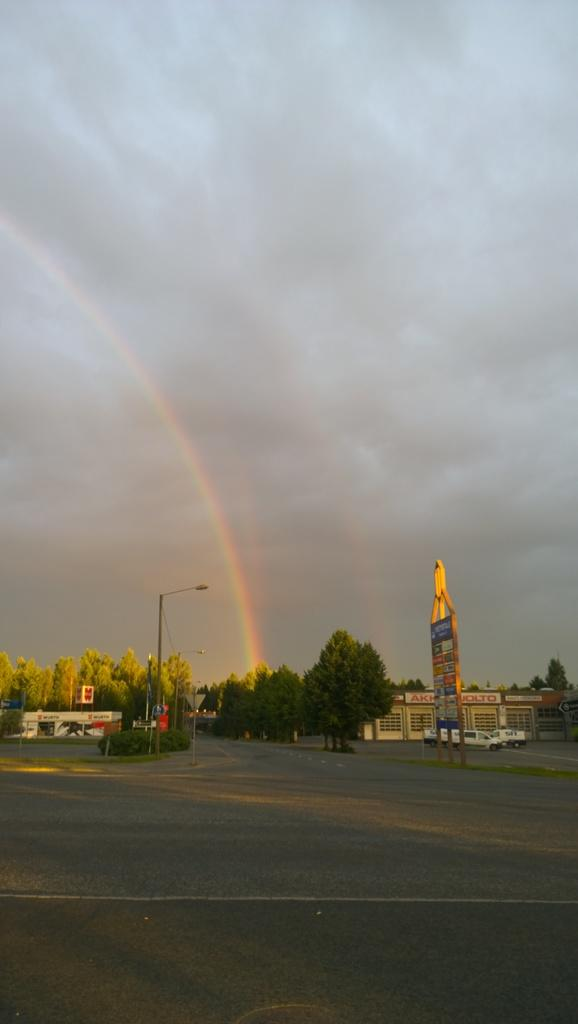What type of vegetation can be seen in the image? There are trees in the image. What structures are present in the image? There are poles and a building in the image. What type of surface is visible at the bottom of the image? There is a road at the bottom of the image. What can be seen in the background of the image? There is sky visible in the background of the image. What type of vehicles are present in the image? There are cars in the image. What is the board used for in the image? The board's purpose is not clear from the image, but it is present. Can you see a river flowing through the image? There is no river visible in the image. Is there a kitten playing with an insect in the image? There are no animals, including kittens or insects, present in the image. 